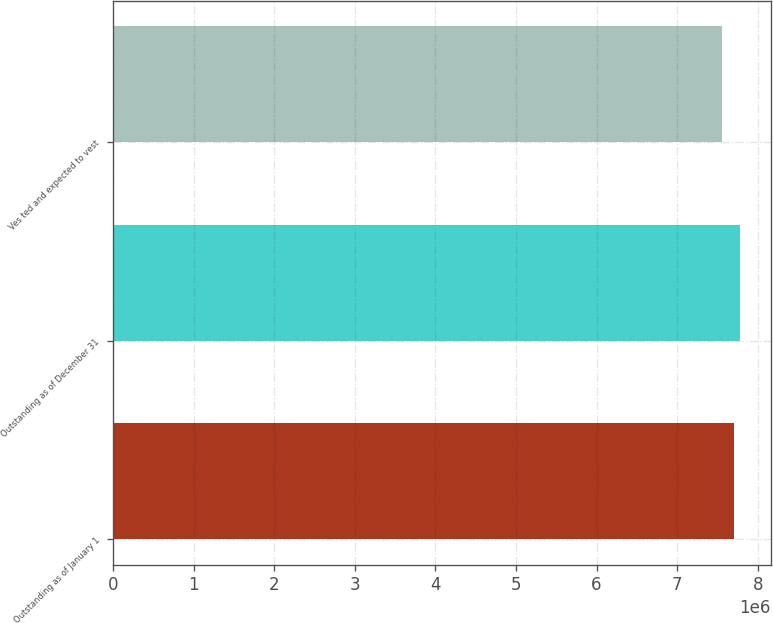Convert chart to OTSL. <chart><loc_0><loc_0><loc_500><loc_500><bar_chart><fcel>Outstanding as of January 1<fcel>Outstanding as of December 31<fcel>Ves ted and expected to vest<nl><fcel>7.70207e+06<fcel>7.77506e+06<fcel>7.55852e+06<nl></chart> 